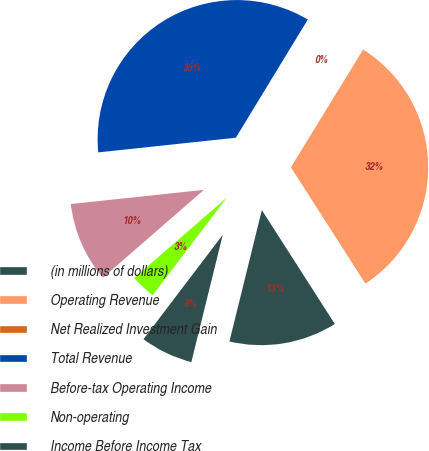Convert chart to OTSL. <chart><loc_0><loc_0><loc_500><loc_500><pie_chart><fcel>(in millions of dollars)<fcel>Operating Revenue<fcel>Net Realized Investment Gain<fcel>Total Revenue<fcel>Before-tax Operating Income<fcel>Non-operating<fcel>Income Before Income Tax<nl><fcel>12.92%<fcel>32.18%<fcel>0.05%<fcel>35.4%<fcel>9.7%<fcel>3.27%<fcel>6.49%<nl></chart> 